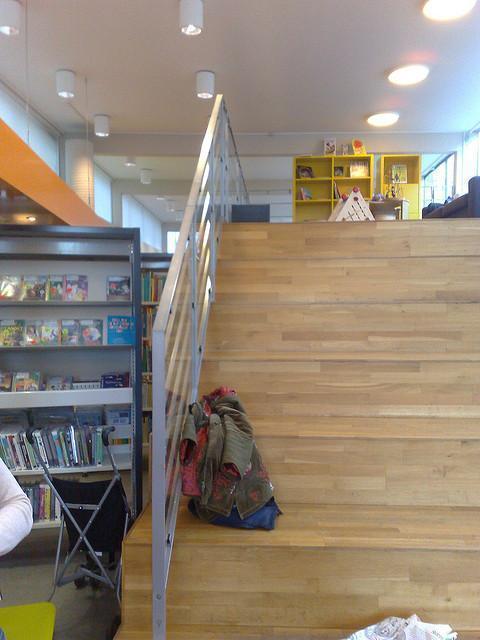What is next to the wooden steps?
Select the accurate response from the four choices given to answer the question.
Options: Railing, dog, cat, egg. Railing. 